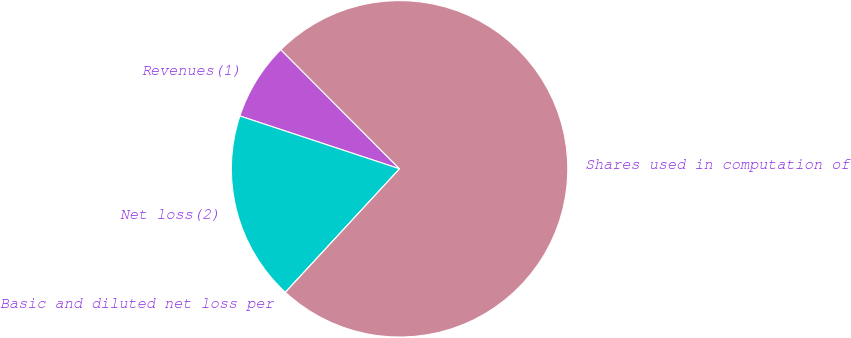Convert chart to OTSL. <chart><loc_0><loc_0><loc_500><loc_500><pie_chart><fcel>Revenues(1)<fcel>Net loss(2)<fcel>Basic and diluted net loss per<fcel>Shares used in computation of<nl><fcel>7.44%<fcel>18.21%<fcel>0.0%<fcel>74.35%<nl></chart> 